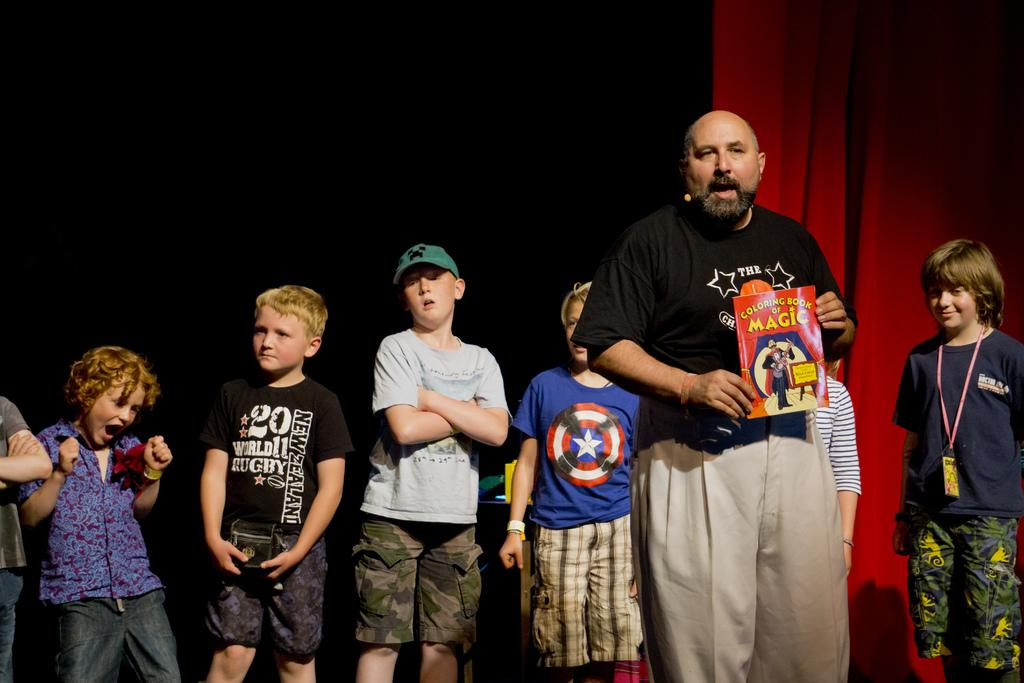What is the man in the image doing? The man is standing in the image and holding a book. Are there any other people in the image besides the man? Yes, there are kids standing behind the man. What can be seen in the background of the image? The background of the image is dark, and there is a curtain visible. Can you tell me how much friction the book is experiencing in the image? There is no information about friction in the image, as it focuses on the man holding a book and the kids standing behind him. --- Facts: 1. There is a car in the image. 2. The car is parked on the street. 3. There are trees on both sides of the street. 4. The sky is visible in the image. 5. The sun is shining in the sky. Absurd Topics: dance, rainbow, parrot Conversation: What is the main subject of the image? The main subject of the image is a car. Where is the car located in the image? The car is parked on the street. What can be seen on both sides of the street in the image? There are trees on both sides of the street. What is visible in the sky in the image? The sky is visible in the image, and the sun is shining. Reasoning: Let's think step by step in order to produce the conversation. We start by identifying the main subject in the image, which is the car. Then, we describe the location of the car, which is parked on the street. Next, we mention the presence of trees on both sides of the street. Finally, we describe the sky and the sun in the image. Absurd Question/Answer: Can you see a parrot perched on the car in the image? No, there is no parrot present in the image. 